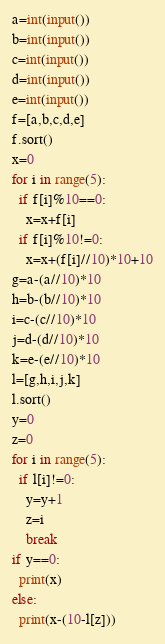<code> <loc_0><loc_0><loc_500><loc_500><_Python_>a=int(input())
b=int(input())
c=int(input())
d=int(input())
e=int(input())
f=[a,b,c,d,e]
f.sort()
x=0
for i in range(5):
  if f[i]%10==0:
    x=x+f[i]
  if f[i]%10!=0:
    x=x+(f[i]//10)*10+10
g=a-(a//10)*10
h=b-(b//10)*10
i=c-(c//10)*10
j=d-(d//10)*10
k=e-(e//10)*10
l=[g,h,i,j,k]
l.sort()
y=0
z=0
for i in range(5):
  if l[i]!=0:
    y=y+1
    z=i
    break
if y==0:
  print(x)
else:
  print(x-(10-l[z]))</code> 